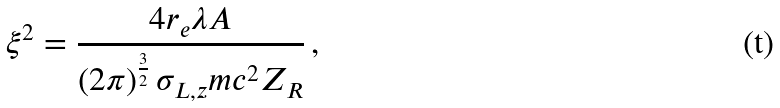<formula> <loc_0><loc_0><loc_500><loc_500>\xi ^ { 2 } = \frac { 4 r _ { e } \lambda A } { \left ( 2 \pi \right ) ^ { \frac { 3 } { 2 } } \sigma _ { L , z } m c ^ { 2 } Z _ { R } } \, ,</formula> 